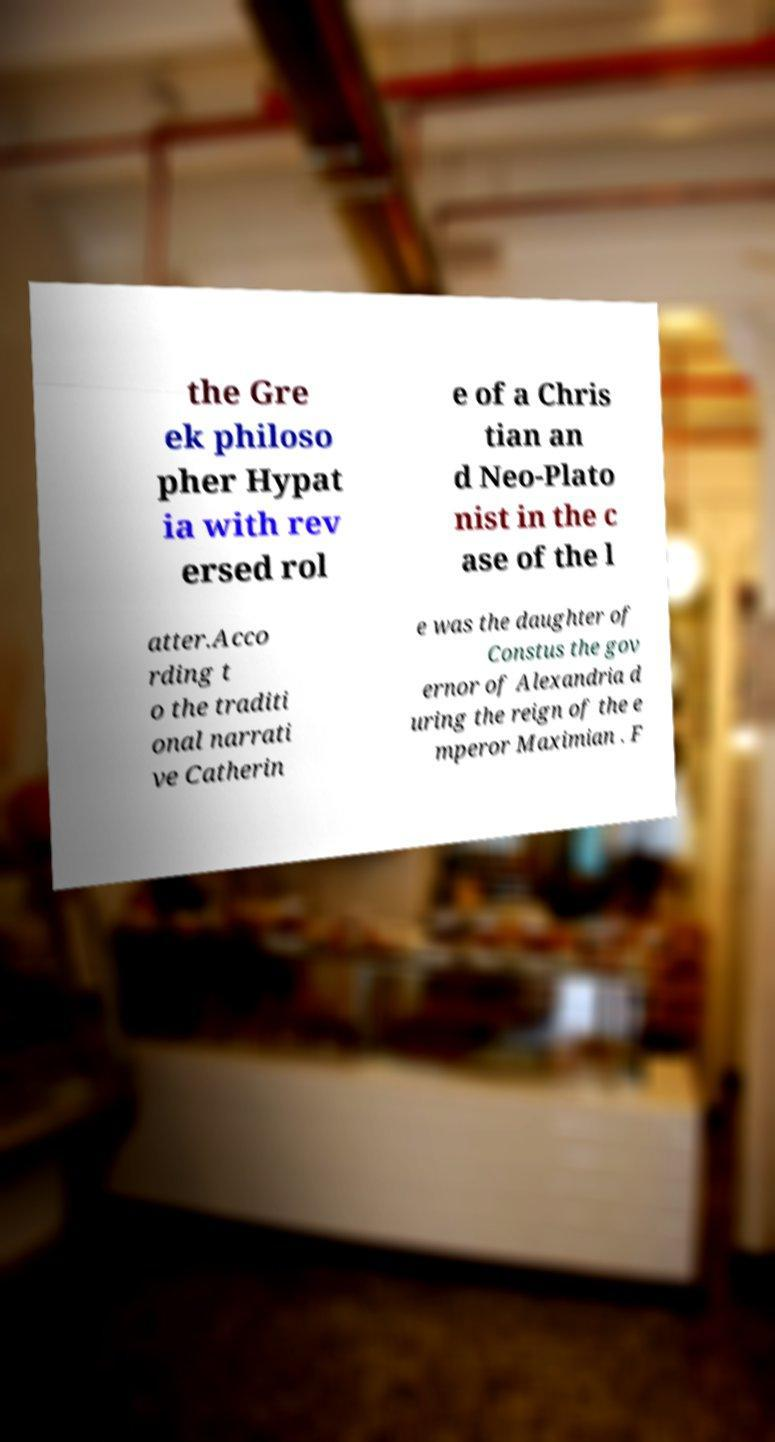Can you read and provide the text displayed in the image?This photo seems to have some interesting text. Can you extract and type it out for me? the Gre ek philoso pher Hypat ia with rev ersed rol e of a Chris tian an d Neo-Plato nist in the c ase of the l atter.Acco rding t o the traditi onal narrati ve Catherin e was the daughter of Constus the gov ernor of Alexandria d uring the reign of the e mperor Maximian . F 